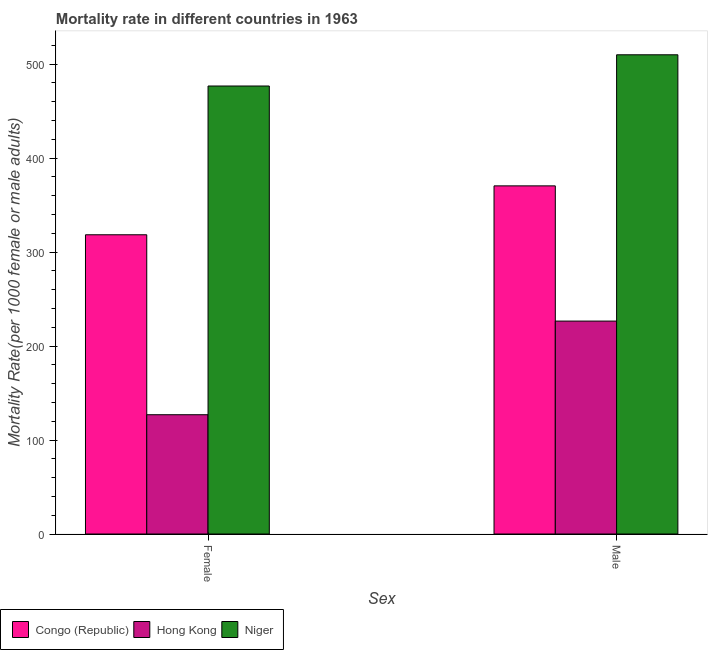How many groups of bars are there?
Your response must be concise. 2. Are the number of bars per tick equal to the number of legend labels?
Offer a terse response. Yes. How many bars are there on the 2nd tick from the left?
Your answer should be very brief. 3. What is the female mortality rate in Hong Kong?
Your response must be concise. 126.92. Across all countries, what is the maximum male mortality rate?
Provide a succinct answer. 509.9. Across all countries, what is the minimum female mortality rate?
Offer a terse response. 126.92. In which country was the female mortality rate maximum?
Offer a very short reply. Niger. In which country was the male mortality rate minimum?
Ensure brevity in your answer.  Hong Kong. What is the total male mortality rate in the graph?
Ensure brevity in your answer.  1106.87. What is the difference between the male mortality rate in Hong Kong and that in Congo (Republic)?
Provide a short and direct response. -143.88. What is the difference between the male mortality rate in Congo (Republic) and the female mortality rate in Niger?
Make the answer very short. -106.26. What is the average male mortality rate per country?
Keep it short and to the point. 368.96. What is the difference between the male mortality rate and female mortality rate in Niger?
Offer a terse response. 33.22. In how many countries, is the female mortality rate greater than 80 ?
Your answer should be very brief. 3. What is the ratio of the male mortality rate in Niger to that in Hong Kong?
Ensure brevity in your answer.  2.25. Is the female mortality rate in Hong Kong less than that in Congo (Republic)?
Your answer should be compact. Yes. What does the 1st bar from the left in Male represents?
Your response must be concise. Congo (Republic). What does the 3rd bar from the right in Male represents?
Your answer should be very brief. Congo (Republic). How many bars are there?
Your answer should be very brief. 6. Are all the bars in the graph horizontal?
Give a very brief answer. No. What is the difference between two consecutive major ticks on the Y-axis?
Offer a terse response. 100. Are the values on the major ticks of Y-axis written in scientific E-notation?
Your response must be concise. No. Does the graph contain any zero values?
Make the answer very short. No. Where does the legend appear in the graph?
Provide a succinct answer. Bottom left. What is the title of the graph?
Your answer should be very brief. Mortality rate in different countries in 1963. Does "Bhutan" appear as one of the legend labels in the graph?
Ensure brevity in your answer.  No. What is the label or title of the X-axis?
Ensure brevity in your answer.  Sex. What is the label or title of the Y-axis?
Offer a very short reply. Mortality Rate(per 1000 female or male adults). What is the Mortality Rate(per 1000 female or male adults) in Congo (Republic) in Female?
Offer a very short reply. 318.39. What is the Mortality Rate(per 1000 female or male adults) in Hong Kong in Female?
Make the answer very short. 126.92. What is the Mortality Rate(per 1000 female or male adults) of Niger in Female?
Ensure brevity in your answer.  476.68. What is the Mortality Rate(per 1000 female or male adults) in Congo (Republic) in Male?
Keep it short and to the point. 370.42. What is the Mortality Rate(per 1000 female or male adults) in Hong Kong in Male?
Provide a short and direct response. 226.55. What is the Mortality Rate(per 1000 female or male adults) of Niger in Male?
Keep it short and to the point. 509.9. Across all Sex, what is the maximum Mortality Rate(per 1000 female or male adults) of Congo (Republic)?
Your response must be concise. 370.42. Across all Sex, what is the maximum Mortality Rate(per 1000 female or male adults) of Hong Kong?
Provide a succinct answer. 226.55. Across all Sex, what is the maximum Mortality Rate(per 1000 female or male adults) in Niger?
Your answer should be very brief. 509.9. Across all Sex, what is the minimum Mortality Rate(per 1000 female or male adults) in Congo (Republic)?
Make the answer very short. 318.39. Across all Sex, what is the minimum Mortality Rate(per 1000 female or male adults) in Hong Kong?
Your answer should be very brief. 126.92. Across all Sex, what is the minimum Mortality Rate(per 1000 female or male adults) of Niger?
Ensure brevity in your answer.  476.68. What is the total Mortality Rate(per 1000 female or male adults) in Congo (Republic) in the graph?
Your answer should be compact. 688.82. What is the total Mortality Rate(per 1000 female or male adults) in Hong Kong in the graph?
Provide a succinct answer. 353.47. What is the total Mortality Rate(per 1000 female or male adults) in Niger in the graph?
Ensure brevity in your answer.  986.58. What is the difference between the Mortality Rate(per 1000 female or male adults) of Congo (Republic) in Female and that in Male?
Make the answer very short. -52.03. What is the difference between the Mortality Rate(per 1000 female or male adults) in Hong Kong in Female and that in Male?
Provide a short and direct response. -99.63. What is the difference between the Mortality Rate(per 1000 female or male adults) in Niger in Female and that in Male?
Keep it short and to the point. -33.22. What is the difference between the Mortality Rate(per 1000 female or male adults) of Congo (Republic) in Female and the Mortality Rate(per 1000 female or male adults) of Hong Kong in Male?
Your answer should be compact. 91.84. What is the difference between the Mortality Rate(per 1000 female or male adults) of Congo (Republic) in Female and the Mortality Rate(per 1000 female or male adults) of Niger in Male?
Keep it short and to the point. -191.5. What is the difference between the Mortality Rate(per 1000 female or male adults) of Hong Kong in Female and the Mortality Rate(per 1000 female or male adults) of Niger in Male?
Your answer should be compact. -382.98. What is the average Mortality Rate(per 1000 female or male adults) of Congo (Republic) per Sex?
Ensure brevity in your answer.  344.41. What is the average Mortality Rate(per 1000 female or male adults) of Hong Kong per Sex?
Keep it short and to the point. 176.73. What is the average Mortality Rate(per 1000 female or male adults) of Niger per Sex?
Your response must be concise. 493.29. What is the difference between the Mortality Rate(per 1000 female or male adults) in Congo (Republic) and Mortality Rate(per 1000 female or male adults) in Hong Kong in Female?
Ensure brevity in your answer.  191.47. What is the difference between the Mortality Rate(per 1000 female or male adults) of Congo (Republic) and Mortality Rate(per 1000 female or male adults) of Niger in Female?
Give a very brief answer. -158.29. What is the difference between the Mortality Rate(per 1000 female or male adults) in Hong Kong and Mortality Rate(per 1000 female or male adults) in Niger in Female?
Keep it short and to the point. -349.76. What is the difference between the Mortality Rate(per 1000 female or male adults) in Congo (Republic) and Mortality Rate(per 1000 female or male adults) in Hong Kong in Male?
Ensure brevity in your answer.  143.88. What is the difference between the Mortality Rate(per 1000 female or male adults) in Congo (Republic) and Mortality Rate(per 1000 female or male adults) in Niger in Male?
Keep it short and to the point. -139.47. What is the difference between the Mortality Rate(per 1000 female or male adults) in Hong Kong and Mortality Rate(per 1000 female or male adults) in Niger in Male?
Ensure brevity in your answer.  -283.35. What is the ratio of the Mortality Rate(per 1000 female or male adults) of Congo (Republic) in Female to that in Male?
Ensure brevity in your answer.  0.86. What is the ratio of the Mortality Rate(per 1000 female or male adults) in Hong Kong in Female to that in Male?
Keep it short and to the point. 0.56. What is the ratio of the Mortality Rate(per 1000 female or male adults) in Niger in Female to that in Male?
Provide a succinct answer. 0.93. What is the difference between the highest and the second highest Mortality Rate(per 1000 female or male adults) of Congo (Republic)?
Offer a terse response. 52.03. What is the difference between the highest and the second highest Mortality Rate(per 1000 female or male adults) of Hong Kong?
Your answer should be compact. 99.63. What is the difference between the highest and the second highest Mortality Rate(per 1000 female or male adults) in Niger?
Offer a very short reply. 33.22. What is the difference between the highest and the lowest Mortality Rate(per 1000 female or male adults) of Congo (Republic)?
Provide a succinct answer. 52.03. What is the difference between the highest and the lowest Mortality Rate(per 1000 female or male adults) of Hong Kong?
Ensure brevity in your answer.  99.63. What is the difference between the highest and the lowest Mortality Rate(per 1000 female or male adults) of Niger?
Make the answer very short. 33.22. 